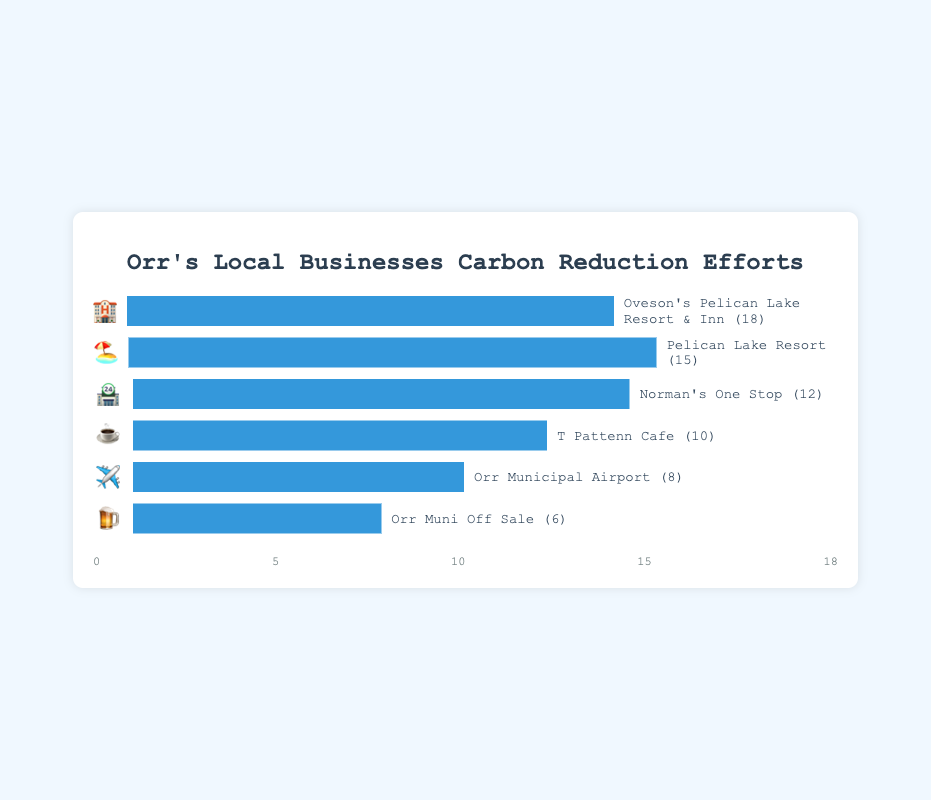Which business has the highest carbon footprint reduction and what is its emoji? The business with the highest carbon footprint reduction is Oveson's Pelican Lake Resort & Inn with a carbon reduction of 18, and its emoji is 🏨.
Answer: Oveson's Pelican Lake Resort & Inn (🏨) What is the total carbon footprint reduction for all businesses combined? To calculate the total carbon reduction, sum up all the reduction values: 18 (🏨) + 15 (🏖️) + 12 (🏪) + 10 (☕) + 8 (✈️) + 6 (🍺) = 69.
Answer: 69 How much more carbon reduction has Pelican Lake Resort achieved compared to Orr Muni Off Sale? Pelican Lake Resort has achieved 15 units of carbon reduction while Orr Muni Off Sale has achieved 6 units. The difference is 15 - 6 = 9.
Answer: 9 Which business has the second-lowest carbon footprint reduction and what is its emoji? The second-lowest carbon footprint reduction is achieved by Orr Municipal Airport with a reduction of 8, and its emoji is ✈️.
Answer: Orr Municipal Airport (✈️) What's the difference in carbon reduction between the top contributor and the lowest contributor? The top contributor, Oveson's Pelican Lake Resort & Inn, has 18 units of reduction, and the lowest contributor, Orr Muni Off Sale, has 6 units. The difference is 18 - 6 = 12.
Answer: 12 What is the average carbon footprint reduction among the businesses? The total reduction is 69, with 6 businesses. The average is 69 / 6 = 11.5.
Answer: 11.5 Order the businesses by their carbon reduction from highest to lowest. First is Oveson's Pelican Lake Resort & Inn (18, 🏨), followed by Pelican Lake Resort (15, 🏖️), then Norman's One Stop (12, 🏪), T Pattenn Cafe (10, ☕), Orr Municipal Airport (8, ✈️), and lastly Orr Muni Off Sale (6, 🍺).
Answer: Oveson's Pelican Lake Resort & Inn > Pelican Lake Resort > Norman's One Stop > T Pattenn Cafe > Orr Municipal Airport > Orr Muni Off Sale What is the combined carbon reduction of tourism-related businesses? The tourism-related businesses are Oveson's Pelican Lake Resort & Inn (18, 🏨) and Pelican Lake Resort (15, 🏖️). Their combined reduction is 18 + 15 = 33.
Answer: 33 If Norman's One Stop wanted to match the carbon reduction of Oveson's Pelican Lake Resort & Inn, how much more reduction is needed? Norman's One Stop has a reduction of 12 units, and Oveson's Pelican Lake Resort & Inn has 18 units. The additional reduction needed is 18 - 12 = 6.
Answer: 6 Which businesses have carbon reductions greater than 10 units, and what are their emojis? The businesses with carbon reductions greater than 10 units are Oveson's Pelican Lake Resort & Inn (18, 🏨), Pelican Lake Resort (15, 🏖️), and Norman's One Stop (12, 🏪).
Answer: Oveson's Pelican Lake Resort & Inn (🏨), Pelican Lake Resort (🏖️), Norman's One Stop (🏪) 